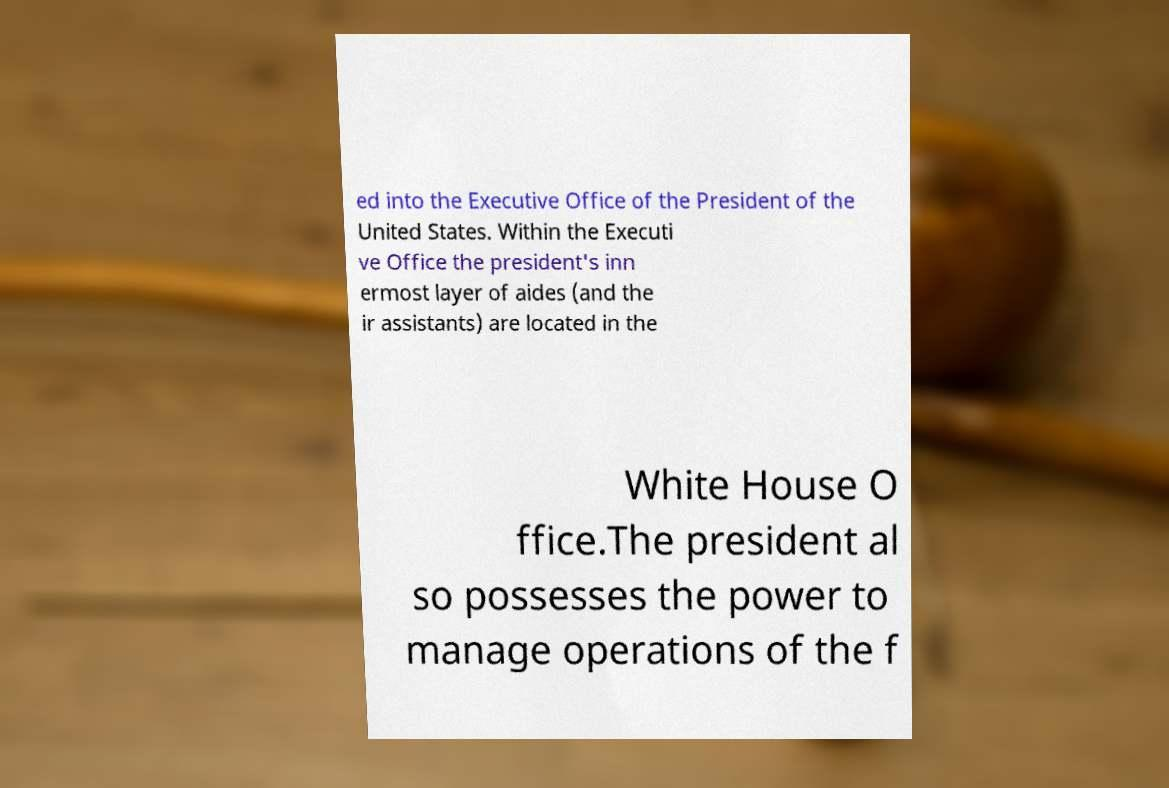Can you read and provide the text displayed in the image?This photo seems to have some interesting text. Can you extract and type it out for me? ed into the Executive Office of the President of the United States. Within the Executi ve Office the president's inn ermost layer of aides (and the ir assistants) are located in the White House O ffice.The president al so possesses the power to manage operations of the f 